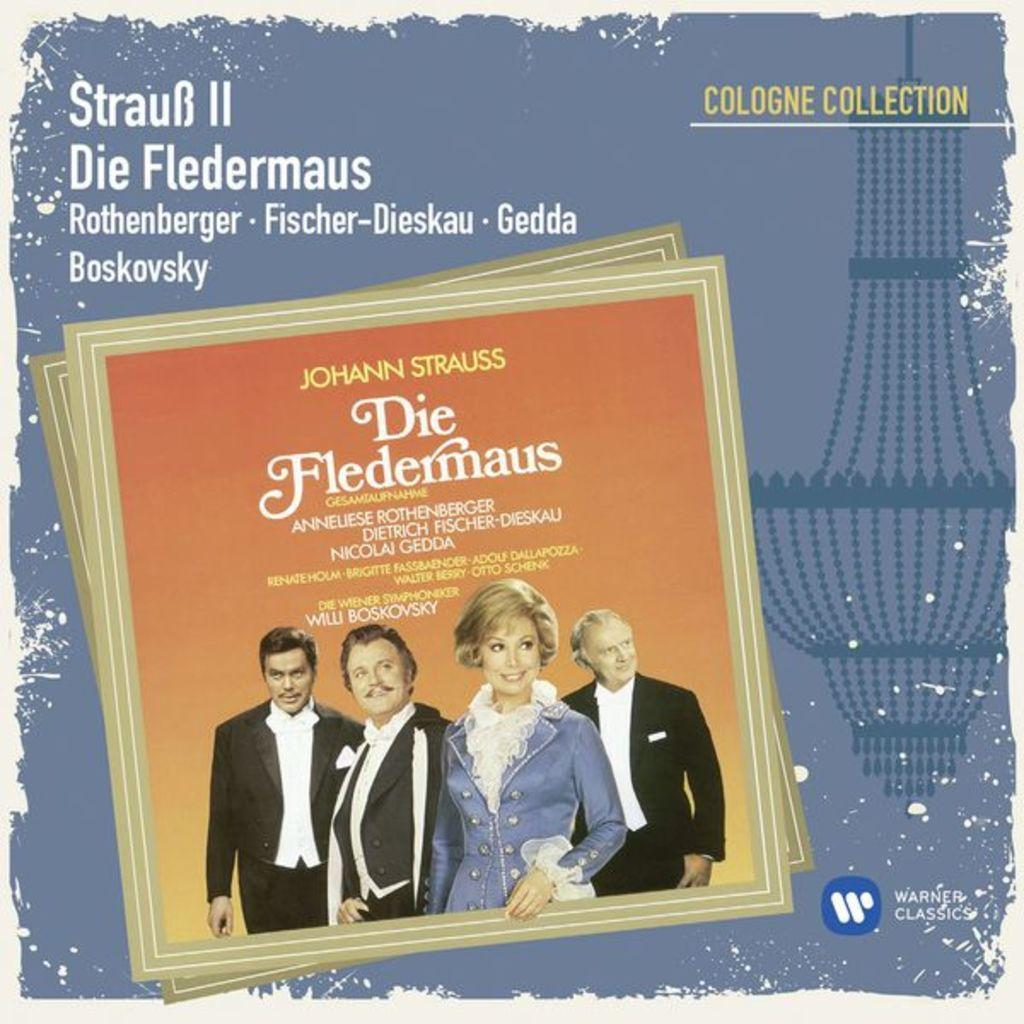What is happening in the image? There are persons standing in the image. What additional information is provided above the image? There is text written above the image. Where can you find more text within the image? There is text written in the right bottom corner of the image. What type of card is being used by the persons in the image? There is no card visible in the image; the persons are simply standing. Is there any celery present in the image? There is no celery present in the image. 